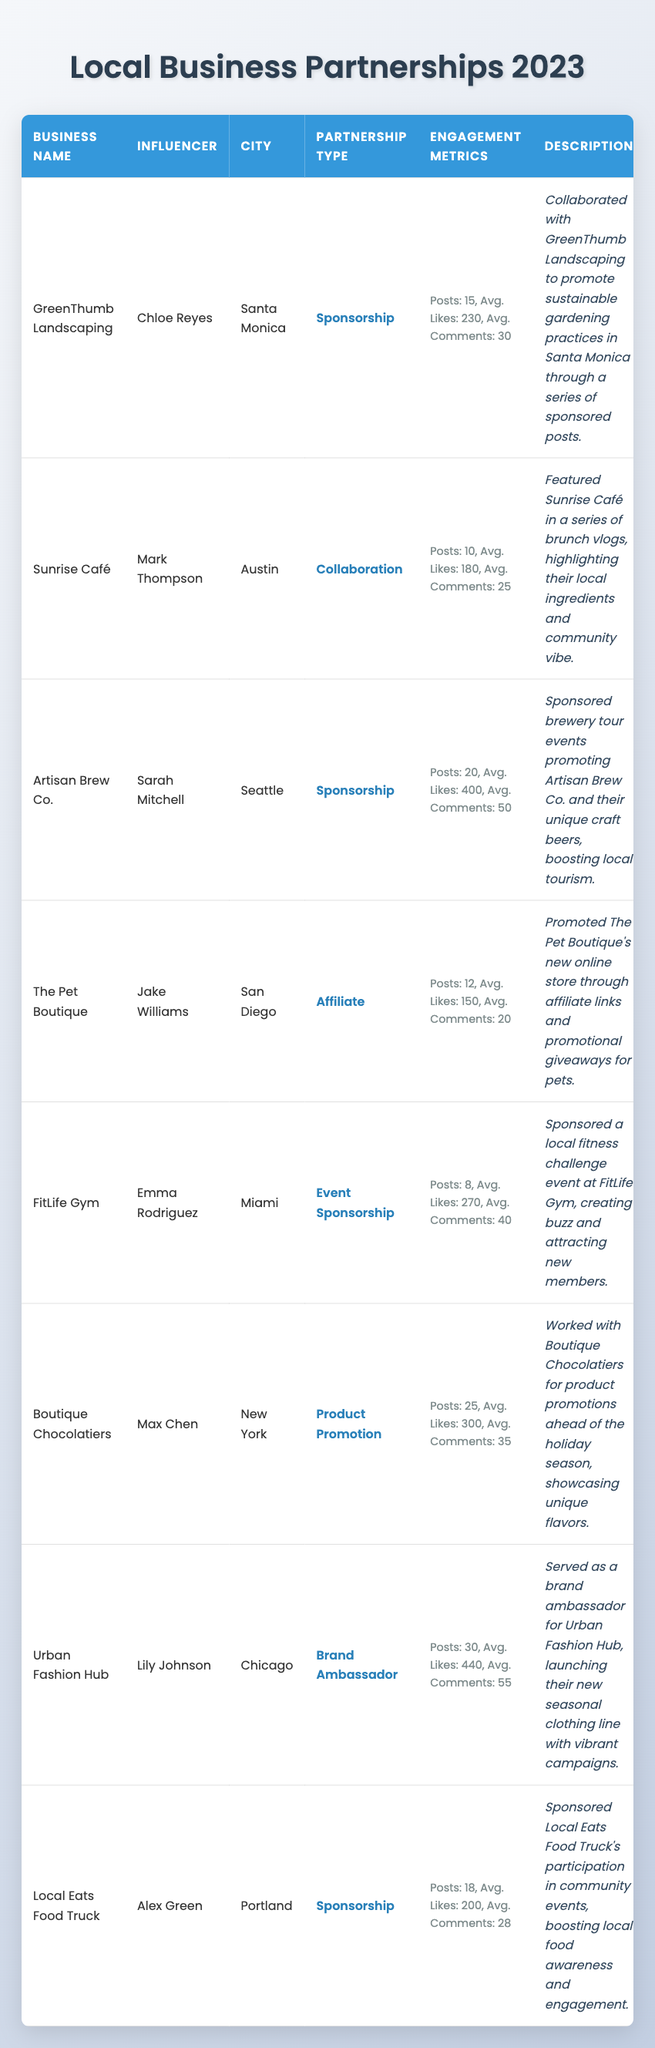What is the partnership type of GreenThumb Landscaping? The partnership type for GreenThumb Landscaping, as stated in the table, is listed next to its name in the "Partnership Type" column, which reads "Sponsorship."
Answer: Sponsorship Which influencer partnered with Local Eats Food Truck? The table shows that Alex Green is the influencer associated with Local Eats Food Truck, mentioned in the "Influencer" column beside the business name.
Answer: Alex Green How many social media posts were made for the Artisan Brew Co. partnership? The "Engagement Metrics" for Artisan Brew Co. indicates that there were a total of 20 social media posts made, which is explicitly stated in that column.
Answer: 20 What is the average number of likes across all partnerships listed in the table? To calculate the average likes, first sum the number of average likes: (230 + 180 + 400 + 150 + 270 + 300 + 440 + 200) = 2170. Then divide by the total number of partnerships (8): 2170 / 8 = 271.25. Thus, the average number of likes is approximately 271.
Answer: 271.25 Did any influencer have more than 30 social media posts? Referring to the table, the influencers with their social media posts show that only Urban Fashion Hub's influencer, Lily Johnson, has 30 posts, which confirms the statement is true.
Answer: Yes Which city had the influencer with the highest average likes per post? By examining the "Average Likes" column, Urban Fashion Hub in Chicago has an average of 440 likes per post, which is the highest value compared to other influencers.
Answer: Chicago What is the total number of average comments from all partnerships? To find the total average comments, add up the average comments for each partnership: (30 + 25 + 50 + 20 + 40 + 35 + 55 + 28) = 278. This sum represents the total number of average comments across all listed partnerships.
Answer: 278 Which influencer worked with a gym in 2023? The table lists FitLife Gym partnered with Emma Rodriguez, indicating she is the influencer associated with this gym.
Answer: Emma Rodriguez Is there any sponsorship that involved promoting a food truck? Local Eats Food Truck's partnership is categorized as "Sponsorship," and the table confirms that this influencer relationship is focused on promoting a food truck at community events. Therefore, this statement is true.
Answer: Yes 